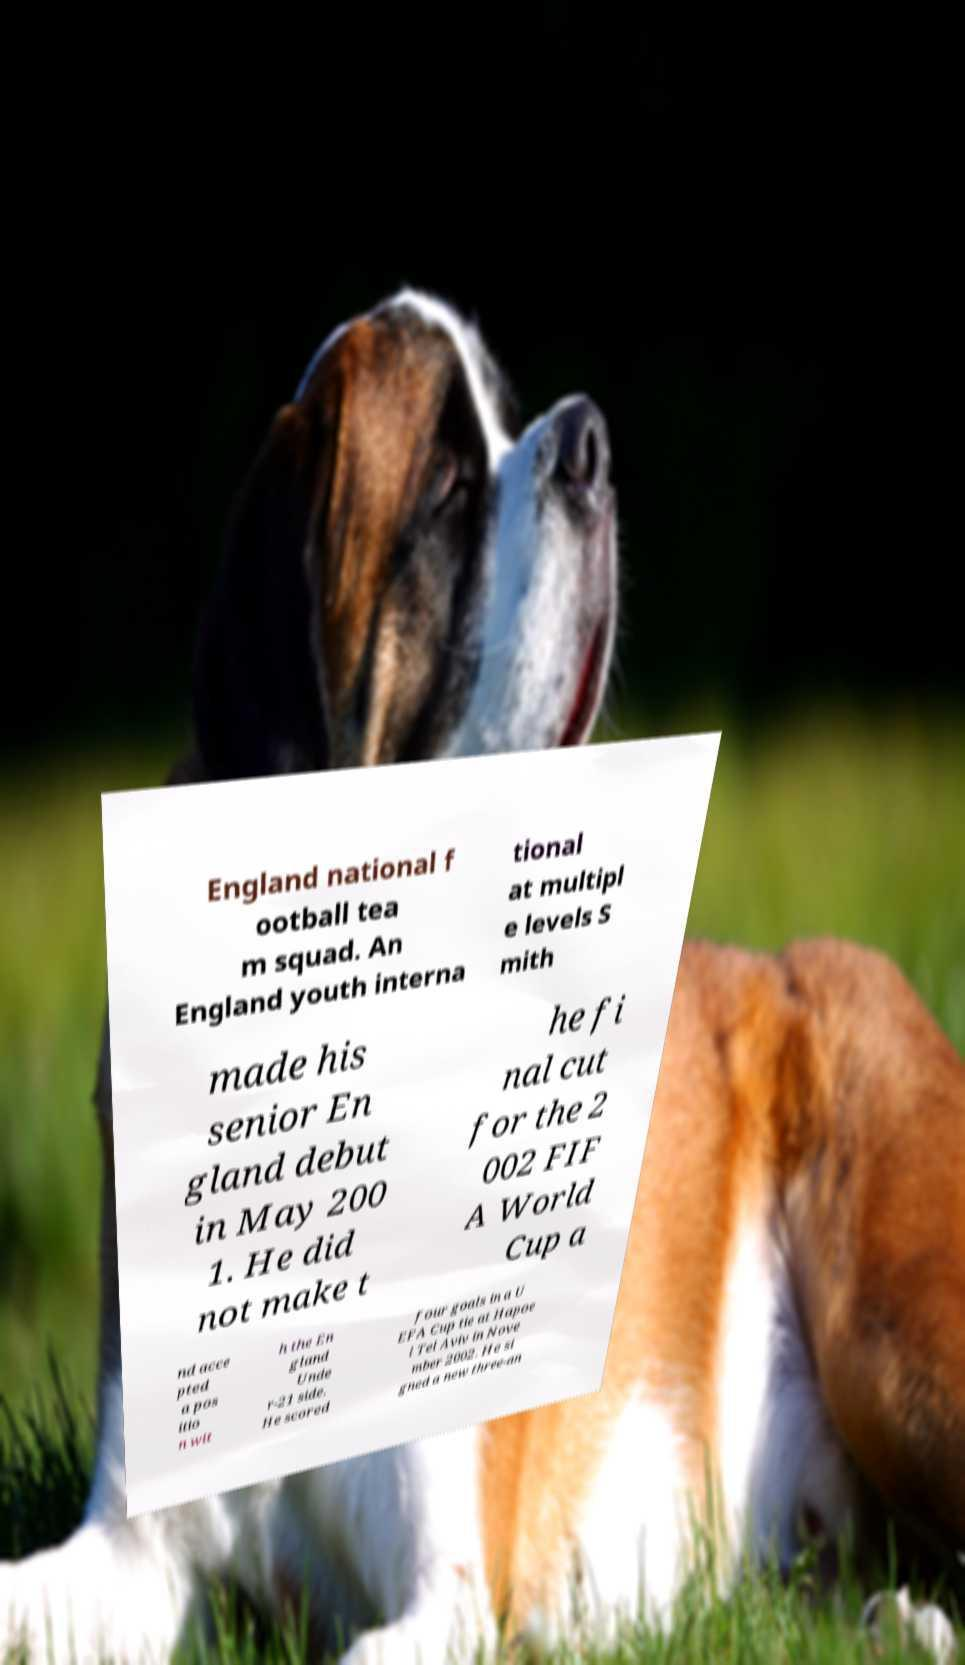Could you extract and type out the text from this image? England national f ootball tea m squad. An England youth interna tional at multipl e levels S mith made his senior En gland debut in May 200 1. He did not make t he fi nal cut for the 2 002 FIF A World Cup a nd acce pted a pos itio n wit h the En gland Unde r-21 side. He scored four goals in a U EFA Cup tie at Hapoe l Tel Aviv in Nove mber 2002. He si gned a new three-an 